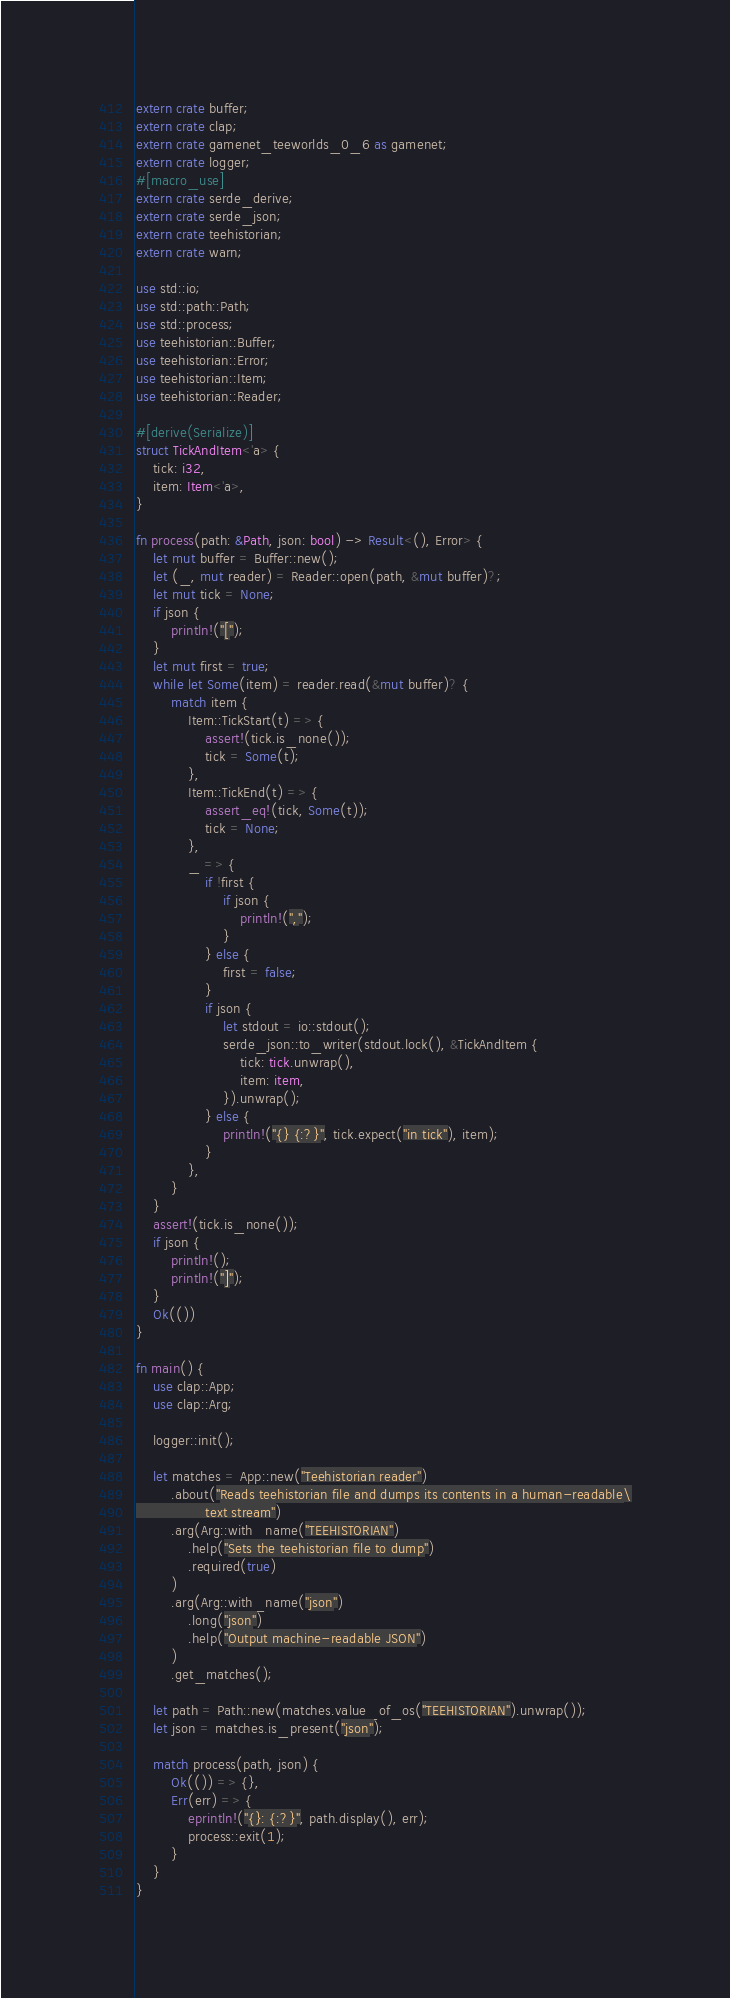Convert code to text. <code><loc_0><loc_0><loc_500><loc_500><_Rust_>extern crate buffer;
extern crate clap;
extern crate gamenet_teeworlds_0_6 as gamenet;
extern crate logger;
#[macro_use]
extern crate serde_derive;
extern crate serde_json;
extern crate teehistorian;
extern crate warn;

use std::io;
use std::path::Path;
use std::process;
use teehistorian::Buffer;
use teehistorian::Error;
use teehistorian::Item;
use teehistorian::Reader;

#[derive(Serialize)]
struct TickAndItem<'a> {
    tick: i32,
    item: Item<'a>,
}

fn process(path: &Path, json: bool) -> Result<(), Error> {
    let mut buffer = Buffer::new();
    let (_, mut reader) = Reader::open(path, &mut buffer)?;
    let mut tick = None;
    if json {
        println!("[");
    }
    let mut first = true;
    while let Some(item) = reader.read(&mut buffer)? {
        match item {
            Item::TickStart(t) => {
                assert!(tick.is_none());
                tick = Some(t);
            },
            Item::TickEnd(t) => {
                assert_eq!(tick, Some(t));
                tick = None;
            },
            _ => {
                if !first {
                    if json {
                        println!(",");
                    }
                } else {
                    first = false;
                }
                if json {
                    let stdout = io::stdout();
                    serde_json::to_writer(stdout.lock(), &TickAndItem {
                        tick: tick.unwrap(),
                        item: item,
                    }).unwrap();
                } else {
                    println!("{} {:?}", tick.expect("in tick"), item);
                }
            },
        }
    }
    assert!(tick.is_none());
    if json {
        println!();
        println!("]");
    }
    Ok(())
}

fn main() {
    use clap::App;
    use clap::Arg;

    logger::init();

    let matches = App::new("Teehistorian reader")
        .about("Reads teehistorian file and dumps its contents in a human-readable\
                text stream")
        .arg(Arg::with_name("TEEHISTORIAN")
            .help("Sets the teehistorian file to dump")
            .required(true)
        )
        .arg(Arg::with_name("json")
            .long("json")
            .help("Output machine-readable JSON")
        )
        .get_matches();

    let path = Path::new(matches.value_of_os("TEEHISTORIAN").unwrap());
    let json = matches.is_present("json");

    match process(path, json) {
        Ok(()) => {},
        Err(err) => {
            eprintln!("{}: {:?}", path.display(), err);
            process::exit(1);
        }
    }
}
</code> 